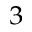Convert formula to latex. <formula><loc_0><loc_0><loc_500><loc_500>^ { 3 }</formula> 